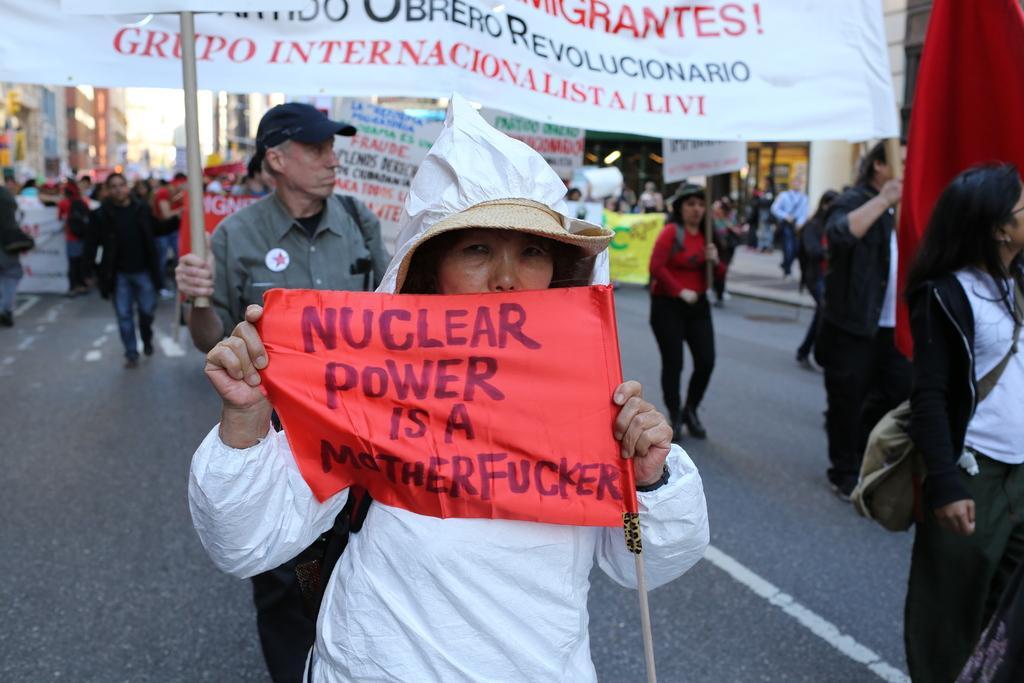In one or two sentences, can you explain what this image depicts? In this image we can see a few people wearing bags and holding banners, on the banners some text is written, in the background we can see some buildings. 